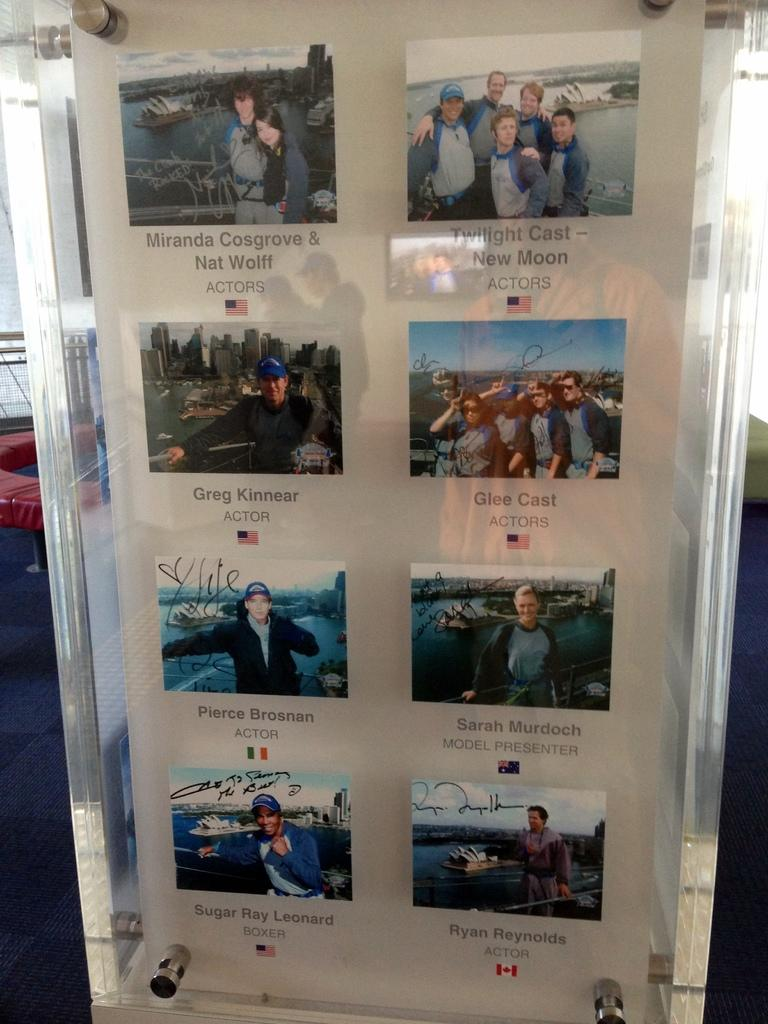<image>
Relay a brief, clear account of the picture shown. A display shows photos signed by famous people such as Greg Kinnear and Ryan Reynolds. 